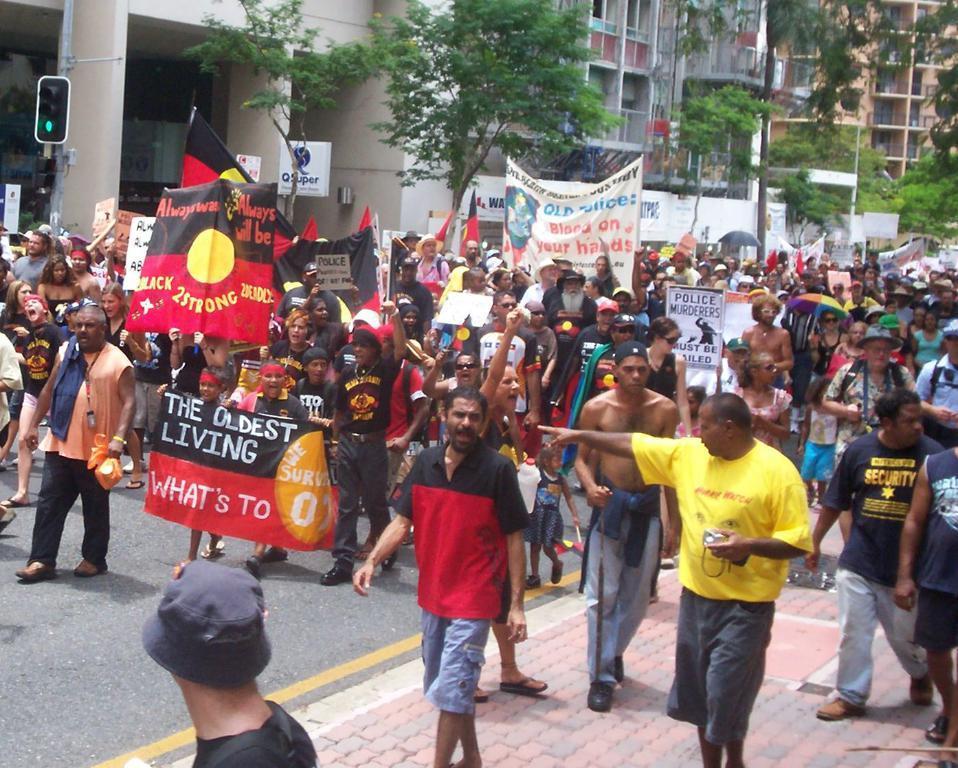Please provide a concise description of this image. In this image I can see in the middle a group of people are walking by holding the placards and banners. On the left side there is the traffic signal. At the back side there are trees and buildings. 